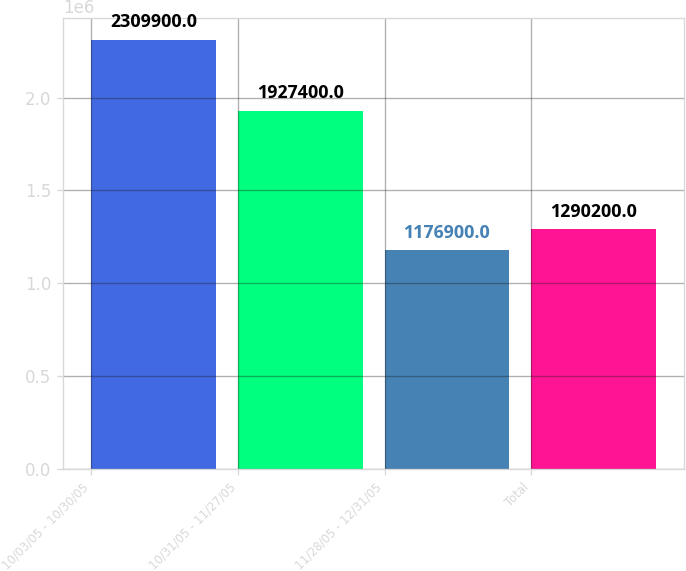<chart> <loc_0><loc_0><loc_500><loc_500><bar_chart><fcel>10/03/05 - 10/30/05<fcel>10/31/05 - 11/27/05<fcel>11/28/05 - 12/31/05<fcel>Total<nl><fcel>2.3099e+06<fcel>1.9274e+06<fcel>1.1769e+06<fcel>1.2902e+06<nl></chart> 